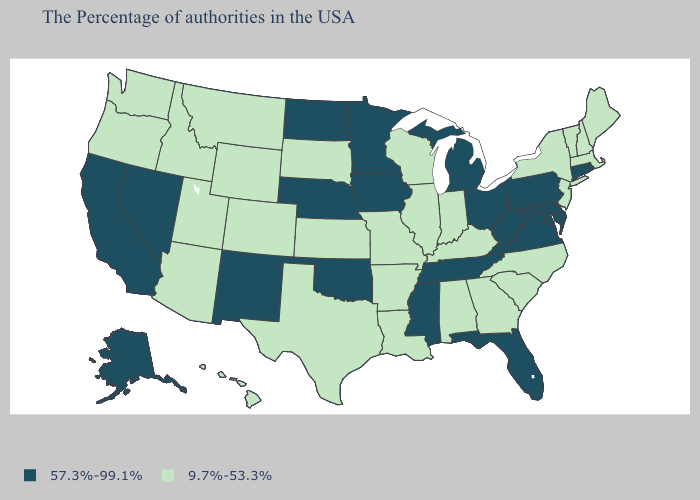What is the value of North Dakota?
Be succinct. 57.3%-99.1%. Name the states that have a value in the range 57.3%-99.1%?
Concise answer only. Rhode Island, Connecticut, Delaware, Maryland, Pennsylvania, Virginia, West Virginia, Ohio, Florida, Michigan, Tennessee, Mississippi, Minnesota, Iowa, Nebraska, Oklahoma, North Dakota, New Mexico, Nevada, California, Alaska. Does Michigan have the lowest value in the USA?
Be succinct. No. What is the value of Florida?
Give a very brief answer. 57.3%-99.1%. Name the states that have a value in the range 57.3%-99.1%?
Short answer required. Rhode Island, Connecticut, Delaware, Maryland, Pennsylvania, Virginia, West Virginia, Ohio, Florida, Michigan, Tennessee, Mississippi, Minnesota, Iowa, Nebraska, Oklahoma, North Dakota, New Mexico, Nevada, California, Alaska. Name the states that have a value in the range 57.3%-99.1%?
Quick response, please. Rhode Island, Connecticut, Delaware, Maryland, Pennsylvania, Virginia, West Virginia, Ohio, Florida, Michigan, Tennessee, Mississippi, Minnesota, Iowa, Nebraska, Oklahoma, North Dakota, New Mexico, Nevada, California, Alaska. What is the value of Michigan?
Short answer required. 57.3%-99.1%. Name the states that have a value in the range 57.3%-99.1%?
Be succinct. Rhode Island, Connecticut, Delaware, Maryland, Pennsylvania, Virginia, West Virginia, Ohio, Florida, Michigan, Tennessee, Mississippi, Minnesota, Iowa, Nebraska, Oklahoma, North Dakota, New Mexico, Nevada, California, Alaska. Among the states that border Washington , which have the lowest value?
Quick response, please. Idaho, Oregon. Which states hav the highest value in the Northeast?
Quick response, please. Rhode Island, Connecticut, Pennsylvania. What is the value of Arizona?
Quick response, please. 9.7%-53.3%. Among the states that border West Virginia , which have the highest value?
Be succinct. Maryland, Pennsylvania, Virginia, Ohio. Does New Hampshire have a lower value than Massachusetts?
Write a very short answer. No. Among the states that border New Mexico , which have the highest value?
Keep it brief. Oklahoma. What is the lowest value in states that border Pennsylvania?
Be succinct. 9.7%-53.3%. 